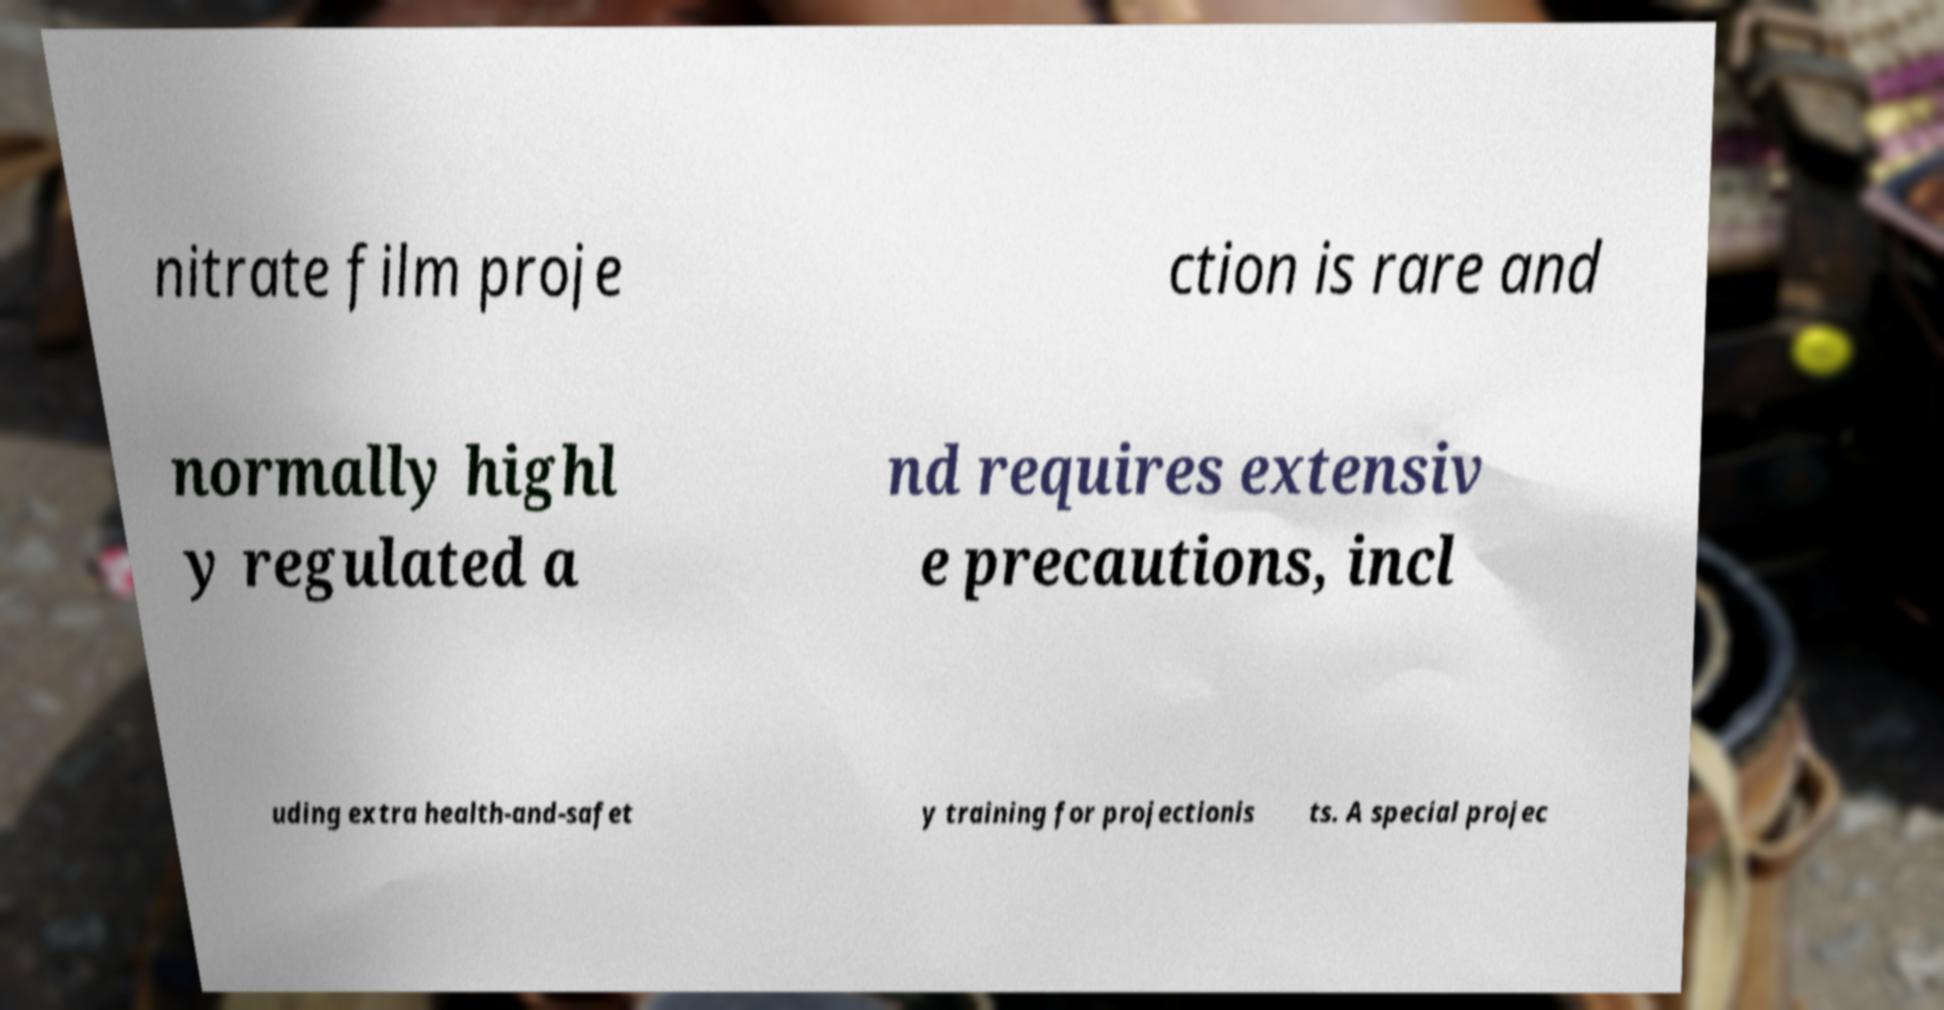Could you assist in decoding the text presented in this image and type it out clearly? nitrate film proje ction is rare and normally highl y regulated a nd requires extensiv e precautions, incl uding extra health-and-safet y training for projectionis ts. A special projec 